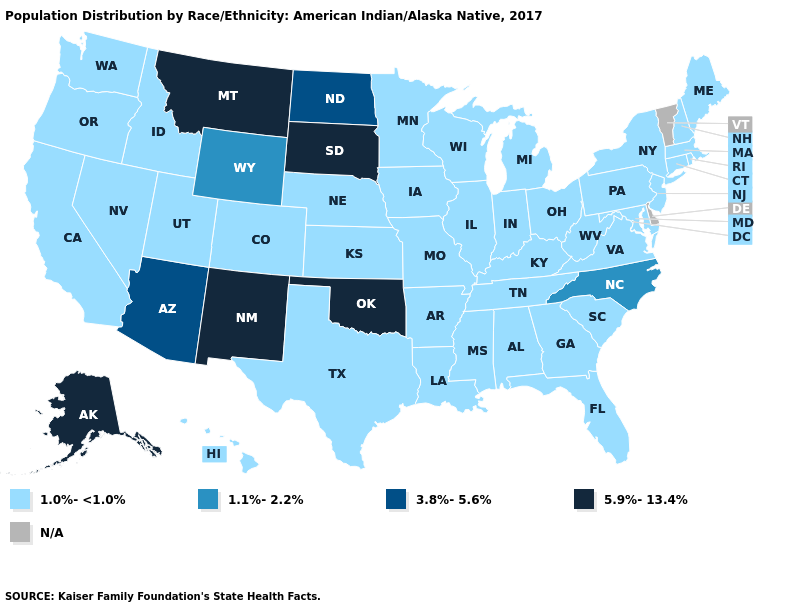Among the states that border Arkansas , does Mississippi have the lowest value?
Be succinct. Yes. Name the states that have a value in the range 1.0%-<1.0%?
Be succinct. Alabama, Arkansas, California, Colorado, Connecticut, Florida, Georgia, Hawaii, Idaho, Illinois, Indiana, Iowa, Kansas, Kentucky, Louisiana, Maine, Maryland, Massachusetts, Michigan, Minnesota, Mississippi, Missouri, Nebraska, Nevada, New Hampshire, New Jersey, New York, Ohio, Oregon, Pennsylvania, Rhode Island, South Carolina, Tennessee, Texas, Utah, Virginia, Washington, West Virginia, Wisconsin. Does the map have missing data?
Keep it brief. Yes. What is the value of Ohio?
Give a very brief answer. 1.0%-<1.0%. Name the states that have a value in the range 3.8%-5.6%?
Write a very short answer. Arizona, North Dakota. What is the highest value in the Northeast ?
Give a very brief answer. 1.0%-<1.0%. What is the value of Arizona?
Give a very brief answer. 3.8%-5.6%. What is the value of South Carolina?
Quick response, please. 1.0%-<1.0%. What is the value of South Dakota?
Give a very brief answer. 5.9%-13.4%. Which states have the lowest value in the South?
Quick response, please. Alabama, Arkansas, Florida, Georgia, Kentucky, Louisiana, Maryland, Mississippi, South Carolina, Tennessee, Texas, Virginia, West Virginia. What is the lowest value in the Northeast?
Give a very brief answer. 1.0%-<1.0%. Name the states that have a value in the range 1.1%-2.2%?
Quick response, please. North Carolina, Wyoming. Name the states that have a value in the range N/A?
Keep it brief. Delaware, Vermont. Name the states that have a value in the range 5.9%-13.4%?
Give a very brief answer. Alaska, Montana, New Mexico, Oklahoma, South Dakota. 